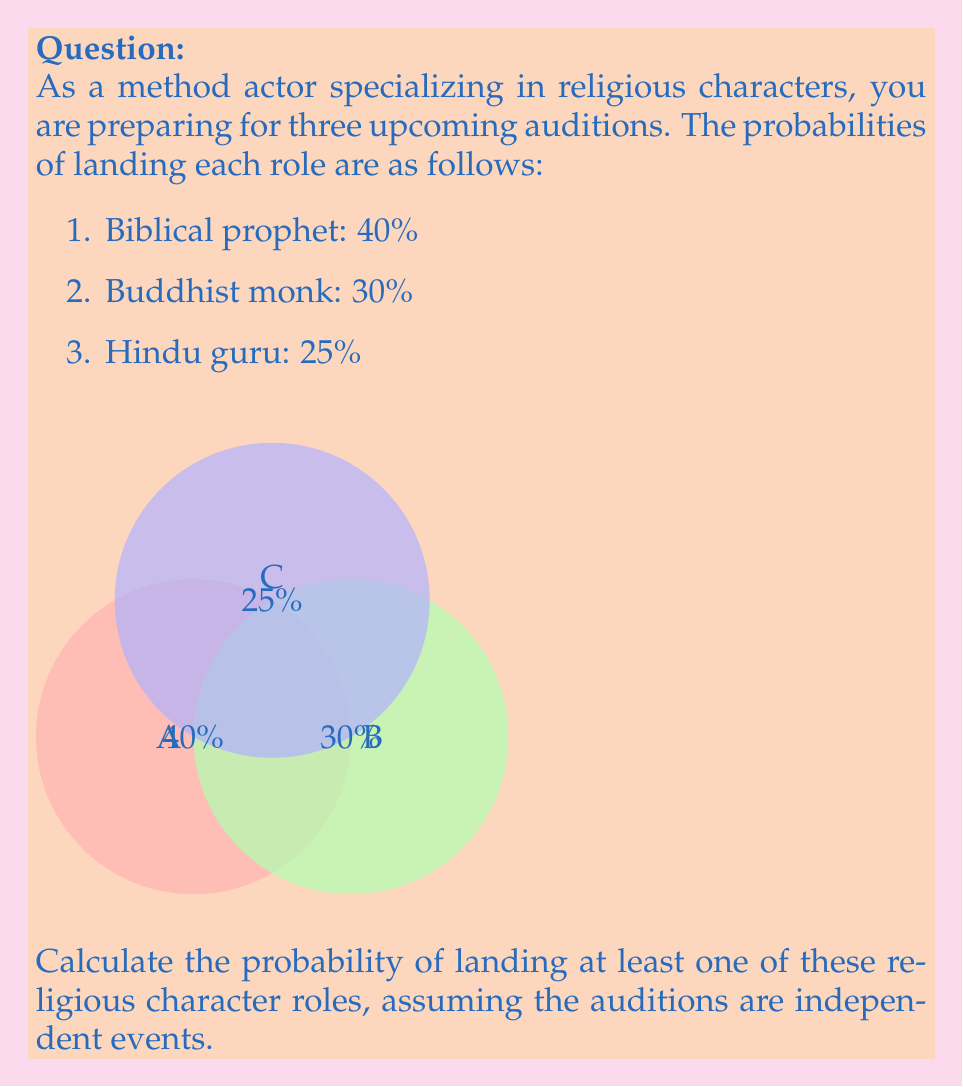Provide a solution to this math problem. To solve this problem, we'll use the complement method:

1) First, let's calculate the probability of not landing any of the roles.

2) The probability of not landing each role is:
   - Biblical prophet: $1 - 0.40 = 0.60$
   - Buddhist monk: $1 - 0.30 = 0.70$
   - Hindu guru: $1 - 0.25 = 0.75$

3) Since the auditions are independent, we multiply these probabilities:

   $P(\text{no roles}) = 0.60 \times 0.70 \times 0.75 = 0.315$

4) The probability of landing at least one role is the complement of landing no roles:

   $P(\text{at least one role}) = 1 - P(\text{no roles})$
   
   $P(\text{at least one role}) = 1 - 0.315 = 0.685$

5) Convert to a percentage:

   $0.685 \times 100\% = 68.5\%$
Answer: 68.5% 